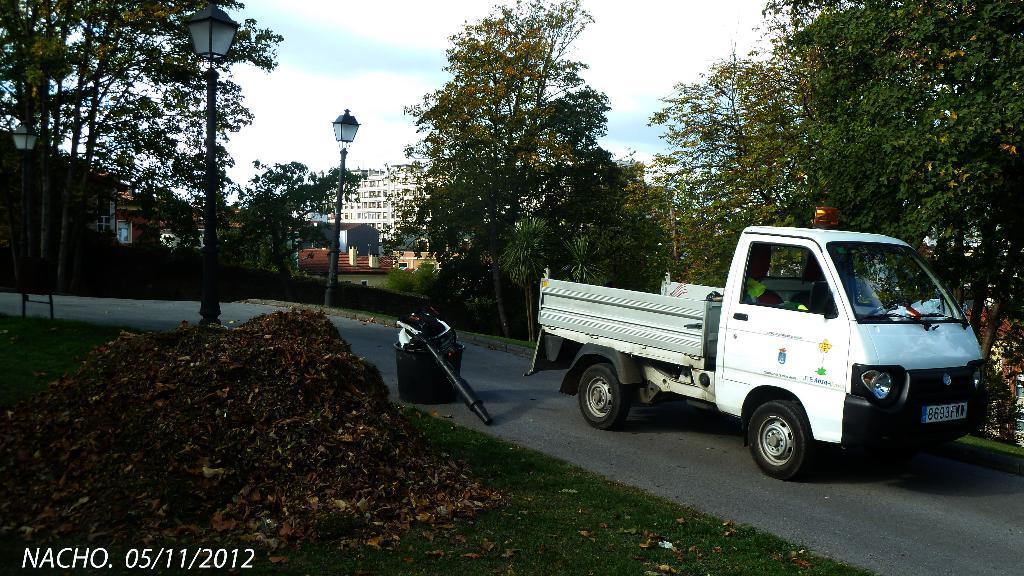Can you describe this image briefly? This image is taken in outdoors. In the left side of the image there is ground with grass and there is a heap of dry leaves. In the right side of the image there are few trees and a vehicle on the road. In the background there are many trees, street lights, buildings with windows and doors. At the top of the image there is a sky with clouds. 